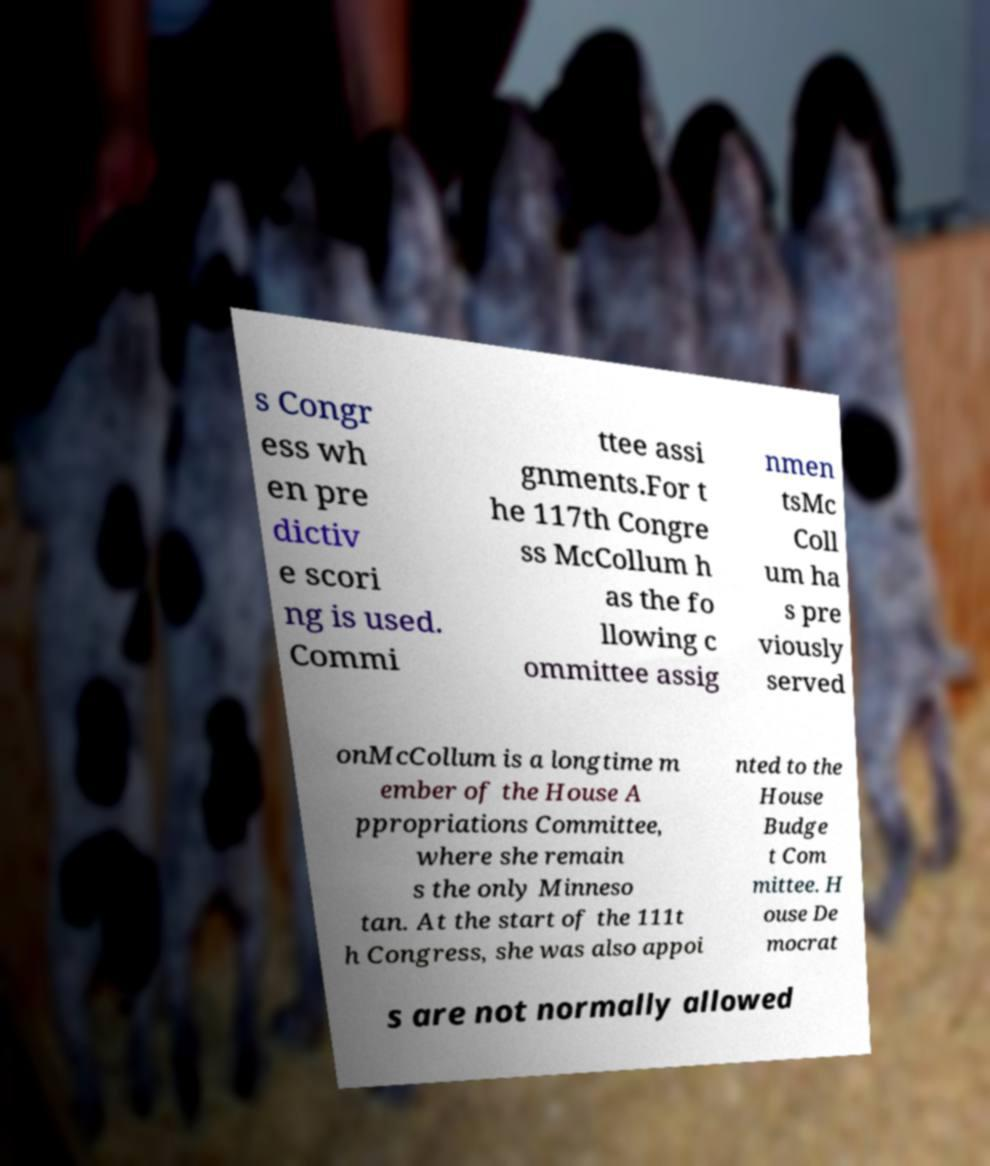Could you extract and type out the text from this image? s Congr ess wh en pre dictiv e scori ng is used. Commi ttee assi gnments.For t he 117th Congre ss McCollum h as the fo llowing c ommittee assig nmen tsMc Coll um ha s pre viously served onMcCollum is a longtime m ember of the House A ppropriations Committee, where she remain s the only Minneso tan. At the start of the 111t h Congress, she was also appoi nted to the House Budge t Com mittee. H ouse De mocrat s are not normally allowed 